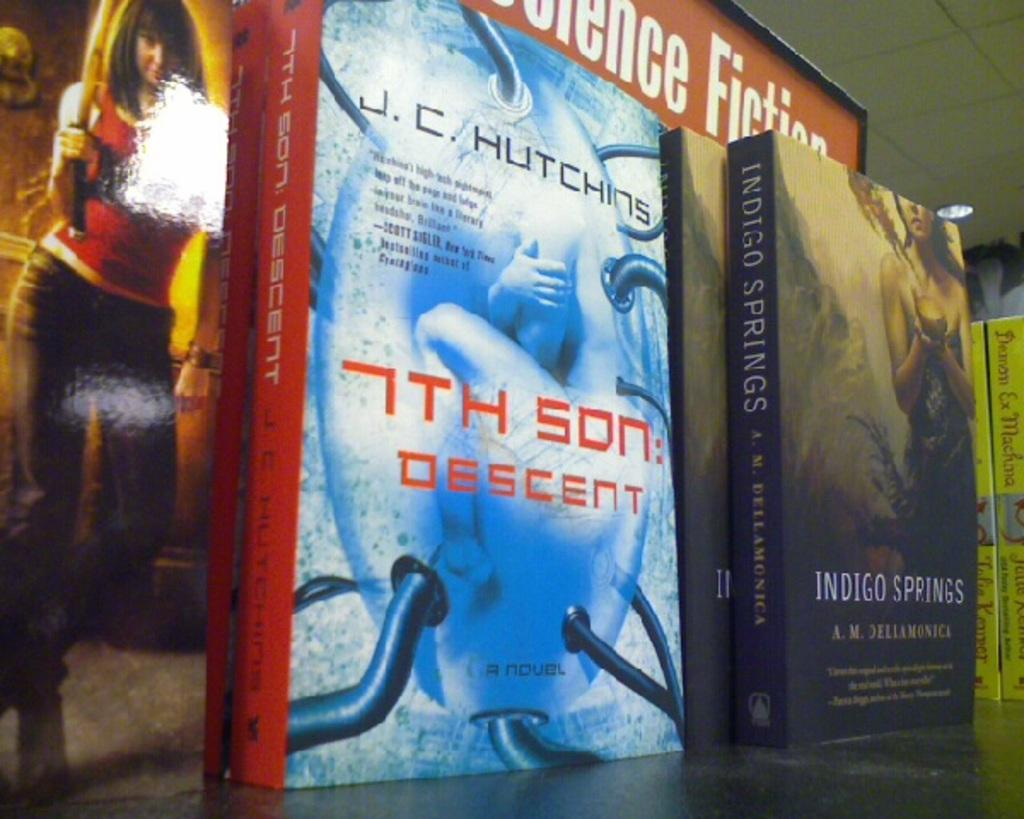<image>
Offer a succinct explanation of the picture presented. Three books sitting in the science fiction section. 